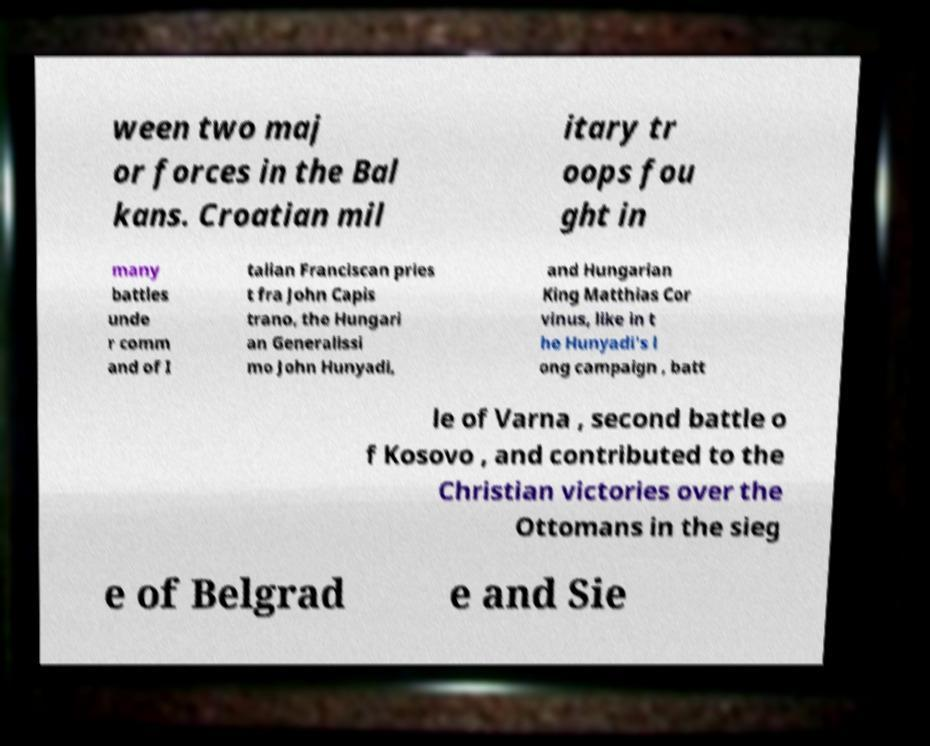There's text embedded in this image that I need extracted. Can you transcribe it verbatim? ween two maj or forces in the Bal kans. Croatian mil itary tr oops fou ght in many battles unde r comm and of I talian Franciscan pries t fra John Capis trano, the Hungari an Generalissi mo John Hunyadi, and Hungarian King Matthias Cor vinus, like in t he Hunyadi's l ong campaign , batt le of Varna , second battle o f Kosovo , and contributed to the Christian victories over the Ottomans in the sieg e of Belgrad e and Sie 